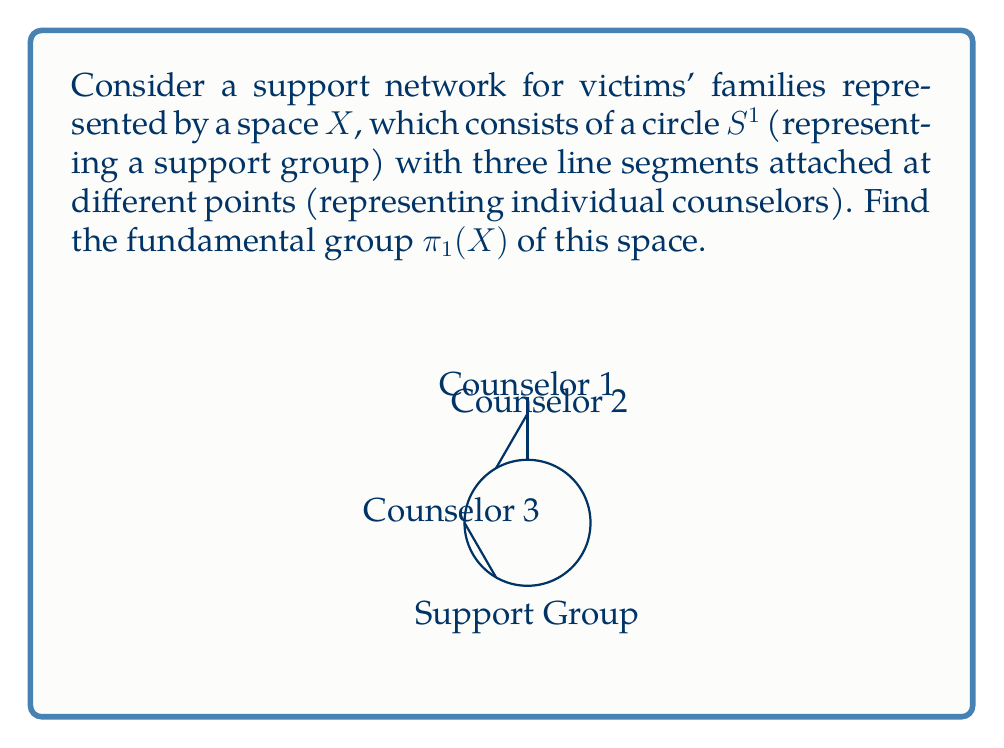Help me with this question. To find the fundamental group of this space, we can follow these steps:

1) First, we need to identify the topology of the space. The space $X$ is homotopy equivalent to a wedge sum of a circle and three lines.

2) The three line segments are contractible, so they don't contribute to the fundamental group. We can contract them to points without changing the homotopy type of the space.

3) After this contraction, our space is homotopy equivalent to a circle with three points marked on it. This is homeomorphic to a circle, $S^1$.

4) The fundamental group of a circle is isomorphic to the integers under addition, denoted as $\mathbb{Z}$.

5) Therefore, the fundamental group of our original space $X$ is isomorphic to $\mathbb{Z}$.

In the context of the support network:
- The generator of this group represents going around the support group once.
- Positive integers represent going around the support group multiple times in one direction.
- Negative integers represent going around the support group multiple times in the opposite direction.
- The identity element (0) represents staying at the starting point or returning to it.

This structure reflects how the support network provides a continuous cycle of support, with the counselors acting as fixed points that don't change the topological nature of the support structure.
Answer: $\pi_1(X) \cong \mathbb{Z}$ 